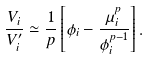<formula> <loc_0><loc_0><loc_500><loc_500>\frac { V _ { i } } { V _ { i } ^ { \prime } } \simeq \frac { 1 } { p } \left [ { \phi _ { i } } - \frac { \mu _ { i } ^ { p } } { \phi _ { i } ^ { p - 1 } } \right ] .</formula> 